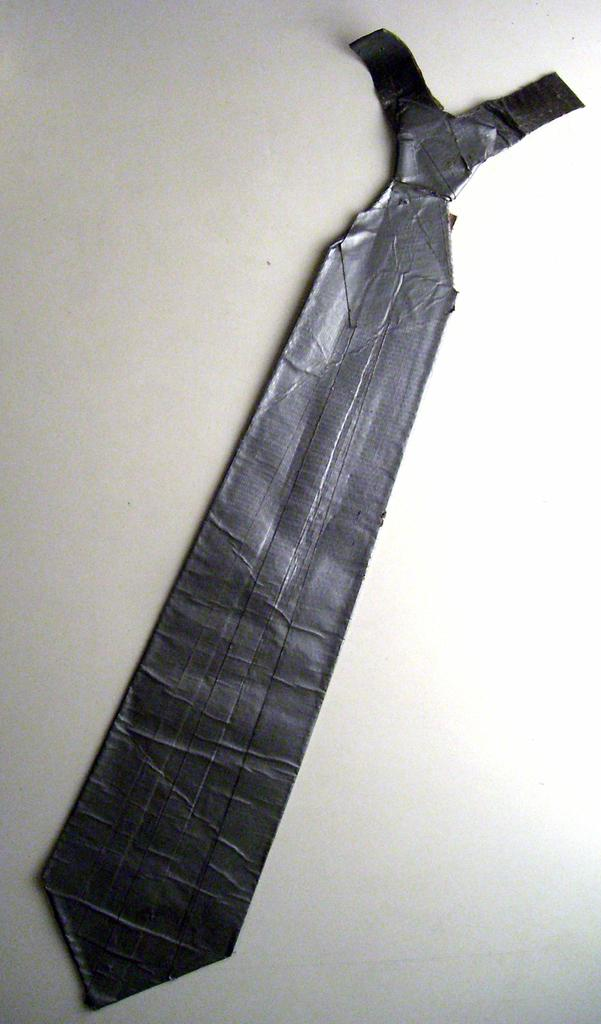What object can be seen on the floor in the image? There is a tie on the floor in the image. What is the color of the tie? The tie is black in color. What type of secretary is shown working in the building in the image? There is no secretary or building present in the image; it only features a black tie placed on the floor. 